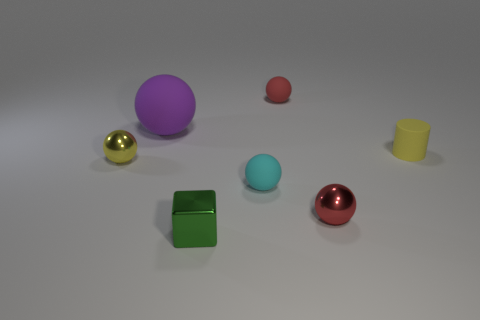There is a yellow ball that is the same size as the green shiny block; what is it made of?
Your answer should be compact. Metal. What number of other things are there of the same color as the small matte cylinder?
Offer a very short reply. 1. Is there any other thing that is the same size as the purple object?
Your response must be concise. No. What number of things are small red metallic spheres or objects right of the shiny block?
Your response must be concise. 4. Do the red thing in front of the small red matte object and the small yellow rubber thing have the same shape?
Offer a terse response. No. There is a tiny cube that is to the left of the red object behind the small red metal ball; how many small cyan matte objects are in front of it?
Your response must be concise. 0. Is there any other thing that has the same shape as the small green metallic thing?
Ensure brevity in your answer.  No. How many objects are tiny green objects or small yellow cylinders?
Give a very brief answer. 2. Is the shape of the tiny red shiny object the same as the small metal object behind the small cyan sphere?
Your answer should be compact. Yes. What is the shape of the tiny red thing in front of the big ball?
Your answer should be very brief. Sphere. 